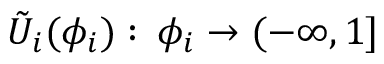Convert formula to latex. <formula><loc_0><loc_0><loc_500><loc_500>\tilde { U } _ { i } ( \phi _ { i } ) \colon \, \phi _ { i } \to ( - \infty , 1 ]</formula> 